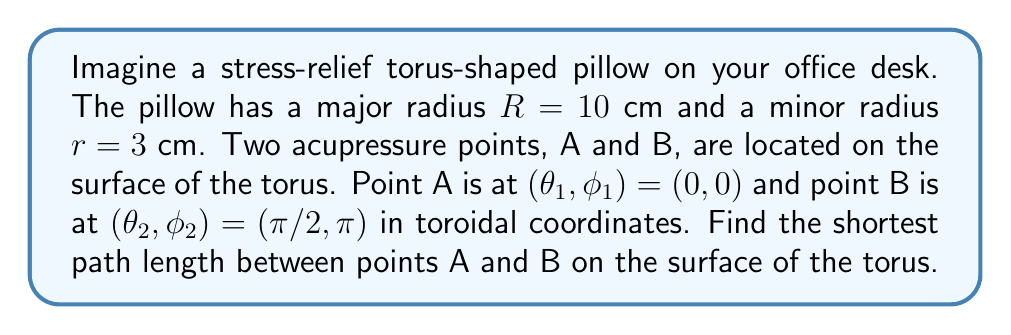Show me your answer to this math problem. Let's approach this step-by-step:

1) In toroidal coordinates, the distance between two points on a torus is given by the formula:

   $$d = \sqrt{((R + r \cos φ_2)\cos θ_2 - (R + r \cos φ_1)\cos θ_1)^2 + ((R + r \cos φ_2)\sin θ_2 - (R + r \cos φ_1)\sin θ_1)^2 + (r \sin φ_2 - r \sin φ_1)^2}$$

2) We're given:
   $R = 10$ cm, $r = 3$ cm
   $(θ_1, φ_1) = (0, 0)$, $(θ_2, φ_2) = (π/2, π)$

3) Let's substitute these values:
   
   $$d = \sqrt{((10 + 3 \cos π)\cos (π/2) - (10 + 3 \cos 0)\cos 0)^2 + ((10 + 3 \cos π)\sin (π/2) - (10 + 3 \cos 0)\sin 0)^2 + (3 \sin π - 3 \sin 0)^2}$$

4) Simplify:
   $\cos π = -1$, $\cos 0 = 1$, $\cos (π/2) = 0$, $\sin (π/2) = 1$, $\sin π = 0$, $\sin 0 = 0$

   $$d = \sqrt{(0 - 13)^2 + (7 - 0)^2 + (0 - 0)^2}$$

5) Calculate:
   
   $$d = \sqrt{169 + 49 + 0} = \sqrt{218} ≈ 14.76 \text{ cm}$$

This is the Euclidean distance between the points, which is a straight line through the torus. However, the question asks for the shortest path on the surface of the torus.

6) For the surface path, we need to use the geodesic distance formula on a torus:

   $$d = \sqrt{R^2(θ_2 - θ_1)^2 + r^2(φ_2 - φ_1)^2}$$

7) Substitute the values:

   $$d = \sqrt{10^2(π/2 - 0)^2 + 3^2(π - 0)^2}$$

8) Calculate:

   $$d = \sqrt{100(π/2)^2 + 9π^2} = \sqrt{25π^2 + 9π^2} = \sqrt{34π^2} = π\sqrt{34} ≈ 18.33 \text{ cm}$$
Answer: $π\sqrt{34}$ cm (≈ 18.33 cm) 